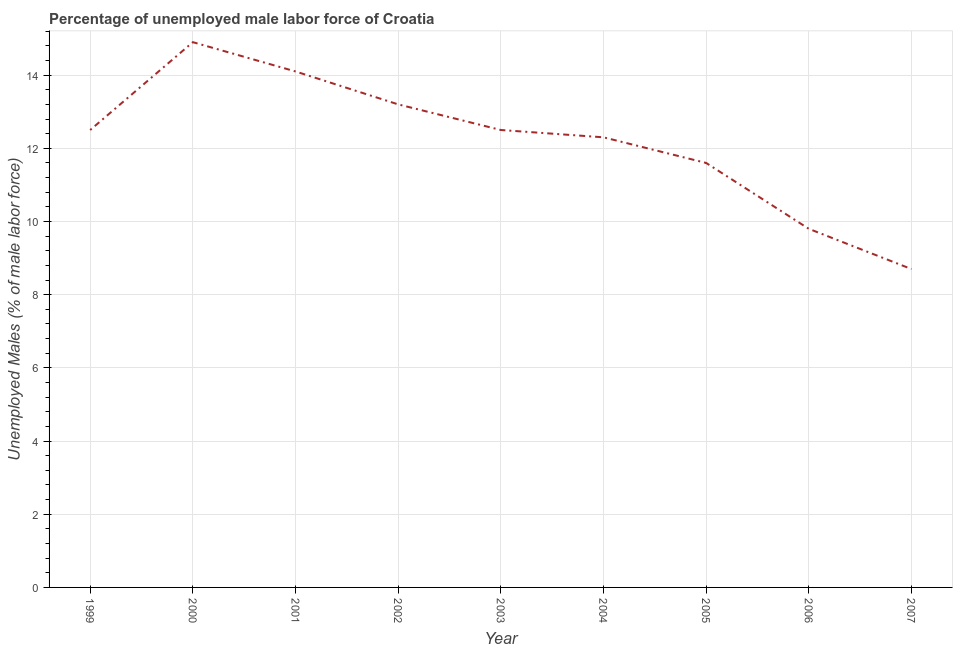What is the total unemployed male labour force in 2006?
Ensure brevity in your answer.  9.8. Across all years, what is the maximum total unemployed male labour force?
Give a very brief answer. 14.9. Across all years, what is the minimum total unemployed male labour force?
Your answer should be compact. 8.7. In which year was the total unemployed male labour force maximum?
Ensure brevity in your answer.  2000. In which year was the total unemployed male labour force minimum?
Provide a succinct answer. 2007. What is the sum of the total unemployed male labour force?
Provide a short and direct response. 109.6. What is the difference between the total unemployed male labour force in 1999 and 2007?
Offer a terse response. 3.8. What is the average total unemployed male labour force per year?
Offer a very short reply. 12.18. What is the median total unemployed male labour force?
Offer a terse response. 12.5. Do a majority of the years between 1999 and 2003 (inclusive) have total unemployed male labour force greater than 5.6 %?
Your response must be concise. Yes. What is the ratio of the total unemployed male labour force in 2004 to that in 2005?
Offer a terse response. 1.06. Is the total unemployed male labour force in 2004 less than that in 2006?
Provide a succinct answer. No. Is the difference between the total unemployed male labour force in 2005 and 2006 greater than the difference between any two years?
Provide a succinct answer. No. What is the difference between the highest and the second highest total unemployed male labour force?
Your answer should be compact. 0.8. What is the difference between the highest and the lowest total unemployed male labour force?
Keep it short and to the point. 6.2. In how many years, is the total unemployed male labour force greater than the average total unemployed male labour force taken over all years?
Keep it short and to the point. 6. Does the total unemployed male labour force monotonically increase over the years?
Provide a short and direct response. No. How many lines are there?
Keep it short and to the point. 1. What is the difference between two consecutive major ticks on the Y-axis?
Provide a short and direct response. 2. Are the values on the major ticks of Y-axis written in scientific E-notation?
Ensure brevity in your answer.  No. What is the title of the graph?
Your response must be concise. Percentage of unemployed male labor force of Croatia. What is the label or title of the Y-axis?
Offer a terse response. Unemployed Males (% of male labor force). What is the Unemployed Males (% of male labor force) of 2000?
Offer a terse response. 14.9. What is the Unemployed Males (% of male labor force) of 2001?
Ensure brevity in your answer.  14.1. What is the Unemployed Males (% of male labor force) of 2002?
Give a very brief answer. 13.2. What is the Unemployed Males (% of male labor force) in 2003?
Provide a short and direct response. 12.5. What is the Unemployed Males (% of male labor force) of 2004?
Make the answer very short. 12.3. What is the Unemployed Males (% of male labor force) in 2005?
Your answer should be compact. 11.6. What is the Unemployed Males (% of male labor force) in 2006?
Your response must be concise. 9.8. What is the Unemployed Males (% of male labor force) in 2007?
Ensure brevity in your answer.  8.7. What is the difference between the Unemployed Males (% of male labor force) in 1999 and 2003?
Keep it short and to the point. 0. What is the difference between the Unemployed Males (% of male labor force) in 1999 and 2004?
Make the answer very short. 0.2. What is the difference between the Unemployed Males (% of male labor force) in 2000 and 2005?
Give a very brief answer. 3.3. What is the difference between the Unemployed Males (% of male labor force) in 2001 and 2002?
Your response must be concise. 0.9. What is the difference between the Unemployed Males (% of male labor force) in 2001 and 2003?
Your response must be concise. 1.6. What is the difference between the Unemployed Males (% of male labor force) in 2001 and 2006?
Ensure brevity in your answer.  4.3. What is the difference between the Unemployed Males (% of male labor force) in 2001 and 2007?
Give a very brief answer. 5.4. What is the difference between the Unemployed Males (% of male labor force) in 2002 and 2006?
Your answer should be compact. 3.4. What is the difference between the Unemployed Males (% of male labor force) in 2003 and 2006?
Provide a short and direct response. 2.7. What is the difference between the Unemployed Males (% of male labor force) in 2004 and 2006?
Keep it short and to the point. 2.5. What is the difference between the Unemployed Males (% of male labor force) in 2005 and 2007?
Offer a terse response. 2.9. What is the ratio of the Unemployed Males (% of male labor force) in 1999 to that in 2000?
Offer a very short reply. 0.84. What is the ratio of the Unemployed Males (% of male labor force) in 1999 to that in 2001?
Provide a succinct answer. 0.89. What is the ratio of the Unemployed Males (% of male labor force) in 1999 to that in 2002?
Give a very brief answer. 0.95. What is the ratio of the Unemployed Males (% of male labor force) in 1999 to that in 2004?
Keep it short and to the point. 1.02. What is the ratio of the Unemployed Males (% of male labor force) in 1999 to that in 2005?
Your answer should be very brief. 1.08. What is the ratio of the Unemployed Males (% of male labor force) in 1999 to that in 2006?
Give a very brief answer. 1.28. What is the ratio of the Unemployed Males (% of male labor force) in 1999 to that in 2007?
Your answer should be very brief. 1.44. What is the ratio of the Unemployed Males (% of male labor force) in 2000 to that in 2001?
Keep it short and to the point. 1.06. What is the ratio of the Unemployed Males (% of male labor force) in 2000 to that in 2002?
Offer a terse response. 1.13. What is the ratio of the Unemployed Males (% of male labor force) in 2000 to that in 2003?
Ensure brevity in your answer.  1.19. What is the ratio of the Unemployed Males (% of male labor force) in 2000 to that in 2004?
Your answer should be compact. 1.21. What is the ratio of the Unemployed Males (% of male labor force) in 2000 to that in 2005?
Offer a terse response. 1.28. What is the ratio of the Unemployed Males (% of male labor force) in 2000 to that in 2006?
Your response must be concise. 1.52. What is the ratio of the Unemployed Males (% of male labor force) in 2000 to that in 2007?
Keep it short and to the point. 1.71. What is the ratio of the Unemployed Males (% of male labor force) in 2001 to that in 2002?
Offer a terse response. 1.07. What is the ratio of the Unemployed Males (% of male labor force) in 2001 to that in 2003?
Your answer should be compact. 1.13. What is the ratio of the Unemployed Males (% of male labor force) in 2001 to that in 2004?
Ensure brevity in your answer.  1.15. What is the ratio of the Unemployed Males (% of male labor force) in 2001 to that in 2005?
Offer a very short reply. 1.22. What is the ratio of the Unemployed Males (% of male labor force) in 2001 to that in 2006?
Give a very brief answer. 1.44. What is the ratio of the Unemployed Males (% of male labor force) in 2001 to that in 2007?
Make the answer very short. 1.62. What is the ratio of the Unemployed Males (% of male labor force) in 2002 to that in 2003?
Give a very brief answer. 1.06. What is the ratio of the Unemployed Males (% of male labor force) in 2002 to that in 2004?
Your answer should be very brief. 1.07. What is the ratio of the Unemployed Males (% of male labor force) in 2002 to that in 2005?
Your answer should be very brief. 1.14. What is the ratio of the Unemployed Males (% of male labor force) in 2002 to that in 2006?
Your answer should be compact. 1.35. What is the ratio of the Unemployed Males (% of male labor force) in 2002 to that in 2007?
Provide a succinct answer. 1.52. What is the ratio of the Unemployed Males (% of male labor force) in 2003 to that in 2004?
Provide a short and direct response. 1.02. What is the ratio of the Unemployed Males (% of male labor force) in 2003 to that in 2005?
Offer a very short reply. 1.08. What is the ratio of the Unemployed Males (% of male labor force) in 2003 to that in 2006?
Provide a succinct answer. 1.28. What is the ratio of the Unemployed Males (% of male labor force) in 2003 to that in 2007?
Your response must be concise. 1.44. What is the ratio of the Unemployed Males (% of male labor force) in 2004 to that in 2005?
Ensure brevity in your answer.  1.06. What is the ratio of the Unemployed Males (% of male labor force) in 2004 to that in 2006?
Make the answer very short. 1.25. What is the ratio of the Unemployed Males (% of male labor force) in 2004 to that in 2007?
Provide a short and direct response. 1.41. What is the ratio of the Unemployed Males (% of male labor force) in 2005 to that in 2006?
Your answer should be very brief. 1.18. What is the ratio of the Unemployed Males (% of male labor force) in 2005 to that in 2007?
Your response must be concise. 1.33. What is the ratio of the Unemployed Males (% of male labor force) in 2006 to that in 2007?
Your answer should be very brief. 1.13. 